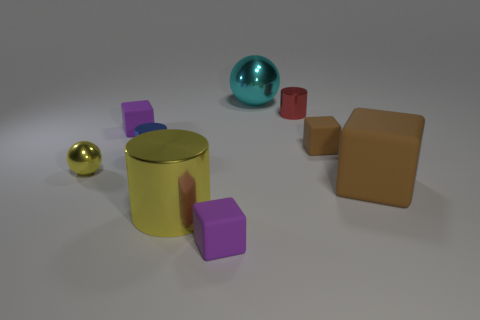Is the color of the small metal ball the same as the large metallic cylinder?
Ensure brevity in your answer.  Yes. What is the size of the yellow shiny thing that is the same shape as the blue metal thing?
Provide a short and direct response. Large. How many small blue cylinders have the same material as the big brown block?
Ensure brevity in your answer.  0. Does the cube that is in front of the big brown matte object have the same material as the blue thing?
Keep it short and to the point. No. Are there an equal number of blue cylinders that are right of the yellow cylinder and big gray shiny blocks?
Your response must be concise. Yes. What is the size of the blue thing?
Make the answer very short. Small. There is a cube that is the same color as the big matte thing; what is its material?
Offer a terse response. Rubber. How many big shiny objects are the same color as the large sphere?
Ensure brevity in your answer.  0. Does the yellow metallic sphere have the same size as the red metallic object?
Your answer should be very brief. Yes. There is a sphere that is on the right side of the purple rubber thing on the right side of the yellow cylinder; what is its size?
Offer a terse response. Large. 